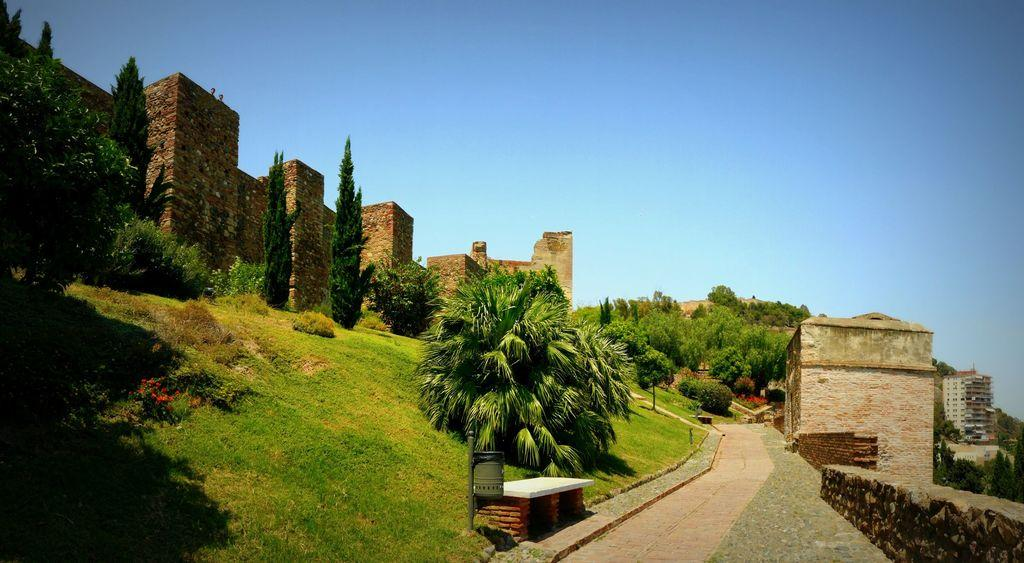Where was the image taken? The image was clicked outside. What can be seen on the right side of the image? There is a small room on the right side of the image. What is located at the bottom of the image? There is a path at the bottom of the image. What type of vegetation is on the left side of the image? There are trees on the left side of the image. What else is present on the left side of the image? There are big walls on the left side of the image. What is visible at the top of the image? The sky is visible at the top of the image. How many apples are hanging from the trees in the image? There are no apples visible in the image; only trees and big walls are present on the left side. 